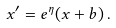<formula> <loc_0><loc_0><loc_500><loc_500>x ^ { \prime } = e ^ { \eta } ( x + b ) \, .</formula> 